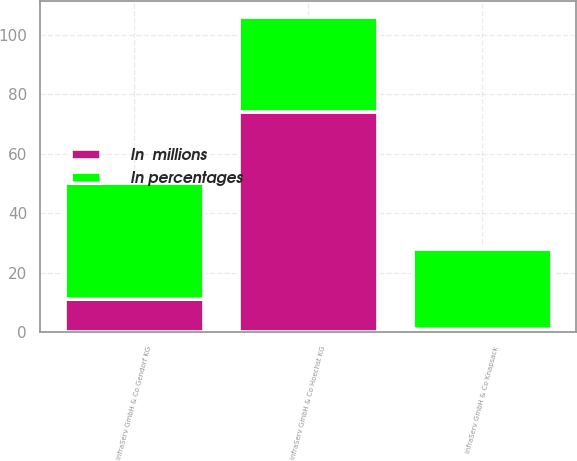Convert chart to OTSL. <chart><loc_0><loc_0><loc_500><loc_500><stacked_bar_chart><ecel><fcel>InfraServ GmbH & Co Gendorf KG<fcel>InfraServ GmbH & Co Knapsack<fcel>InfraServ GmbH & Co Hoechst KG<nl><fcel>In percentages<fcel>39<fcel>27<fcel>32<nl><fcel>In  millions<fcel>11<fcel>1<fcel>74<nl></chart> 